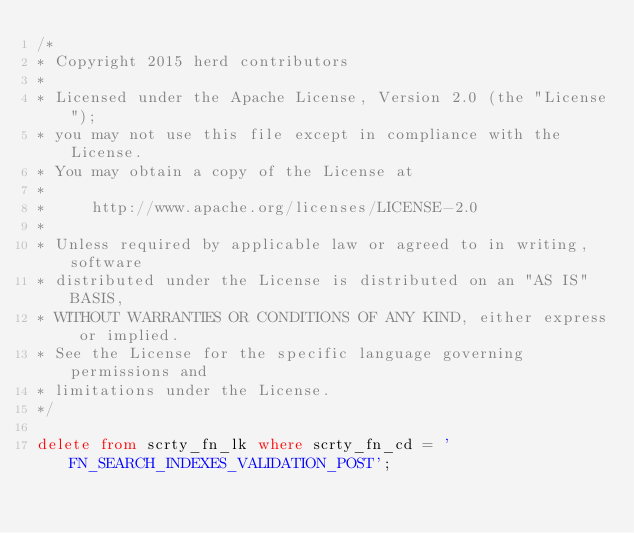Convert code to text. <code><loc_0><loc_0><loc_500><loc_500><_SQL_>/*
* Copyright 2015 herd contributors
*
* Licensed under the Apache License, Version 2.0 (the "License");
* you may not use this file except in compliance with the License.
* You may obtain a copy of the License at
*
*     http://www.apache.org/licenses/LICENSE-2.0
*
* Unless required by applicable law or agreed to in writing, software
* distributed under the License is distributed on an "AS IS" BASIS,
* WITHOUT WARRANTIES OR CONDITIONS OF ANY KIND, either express or implied.
* See the License for the specific language governing permissions and
* limitations under the License.
*/

delete from scrty_fn_lk where scrty_fn_cd = 'FN_SEARCH_INDEXES_VALIDATION_POST';
</code> 